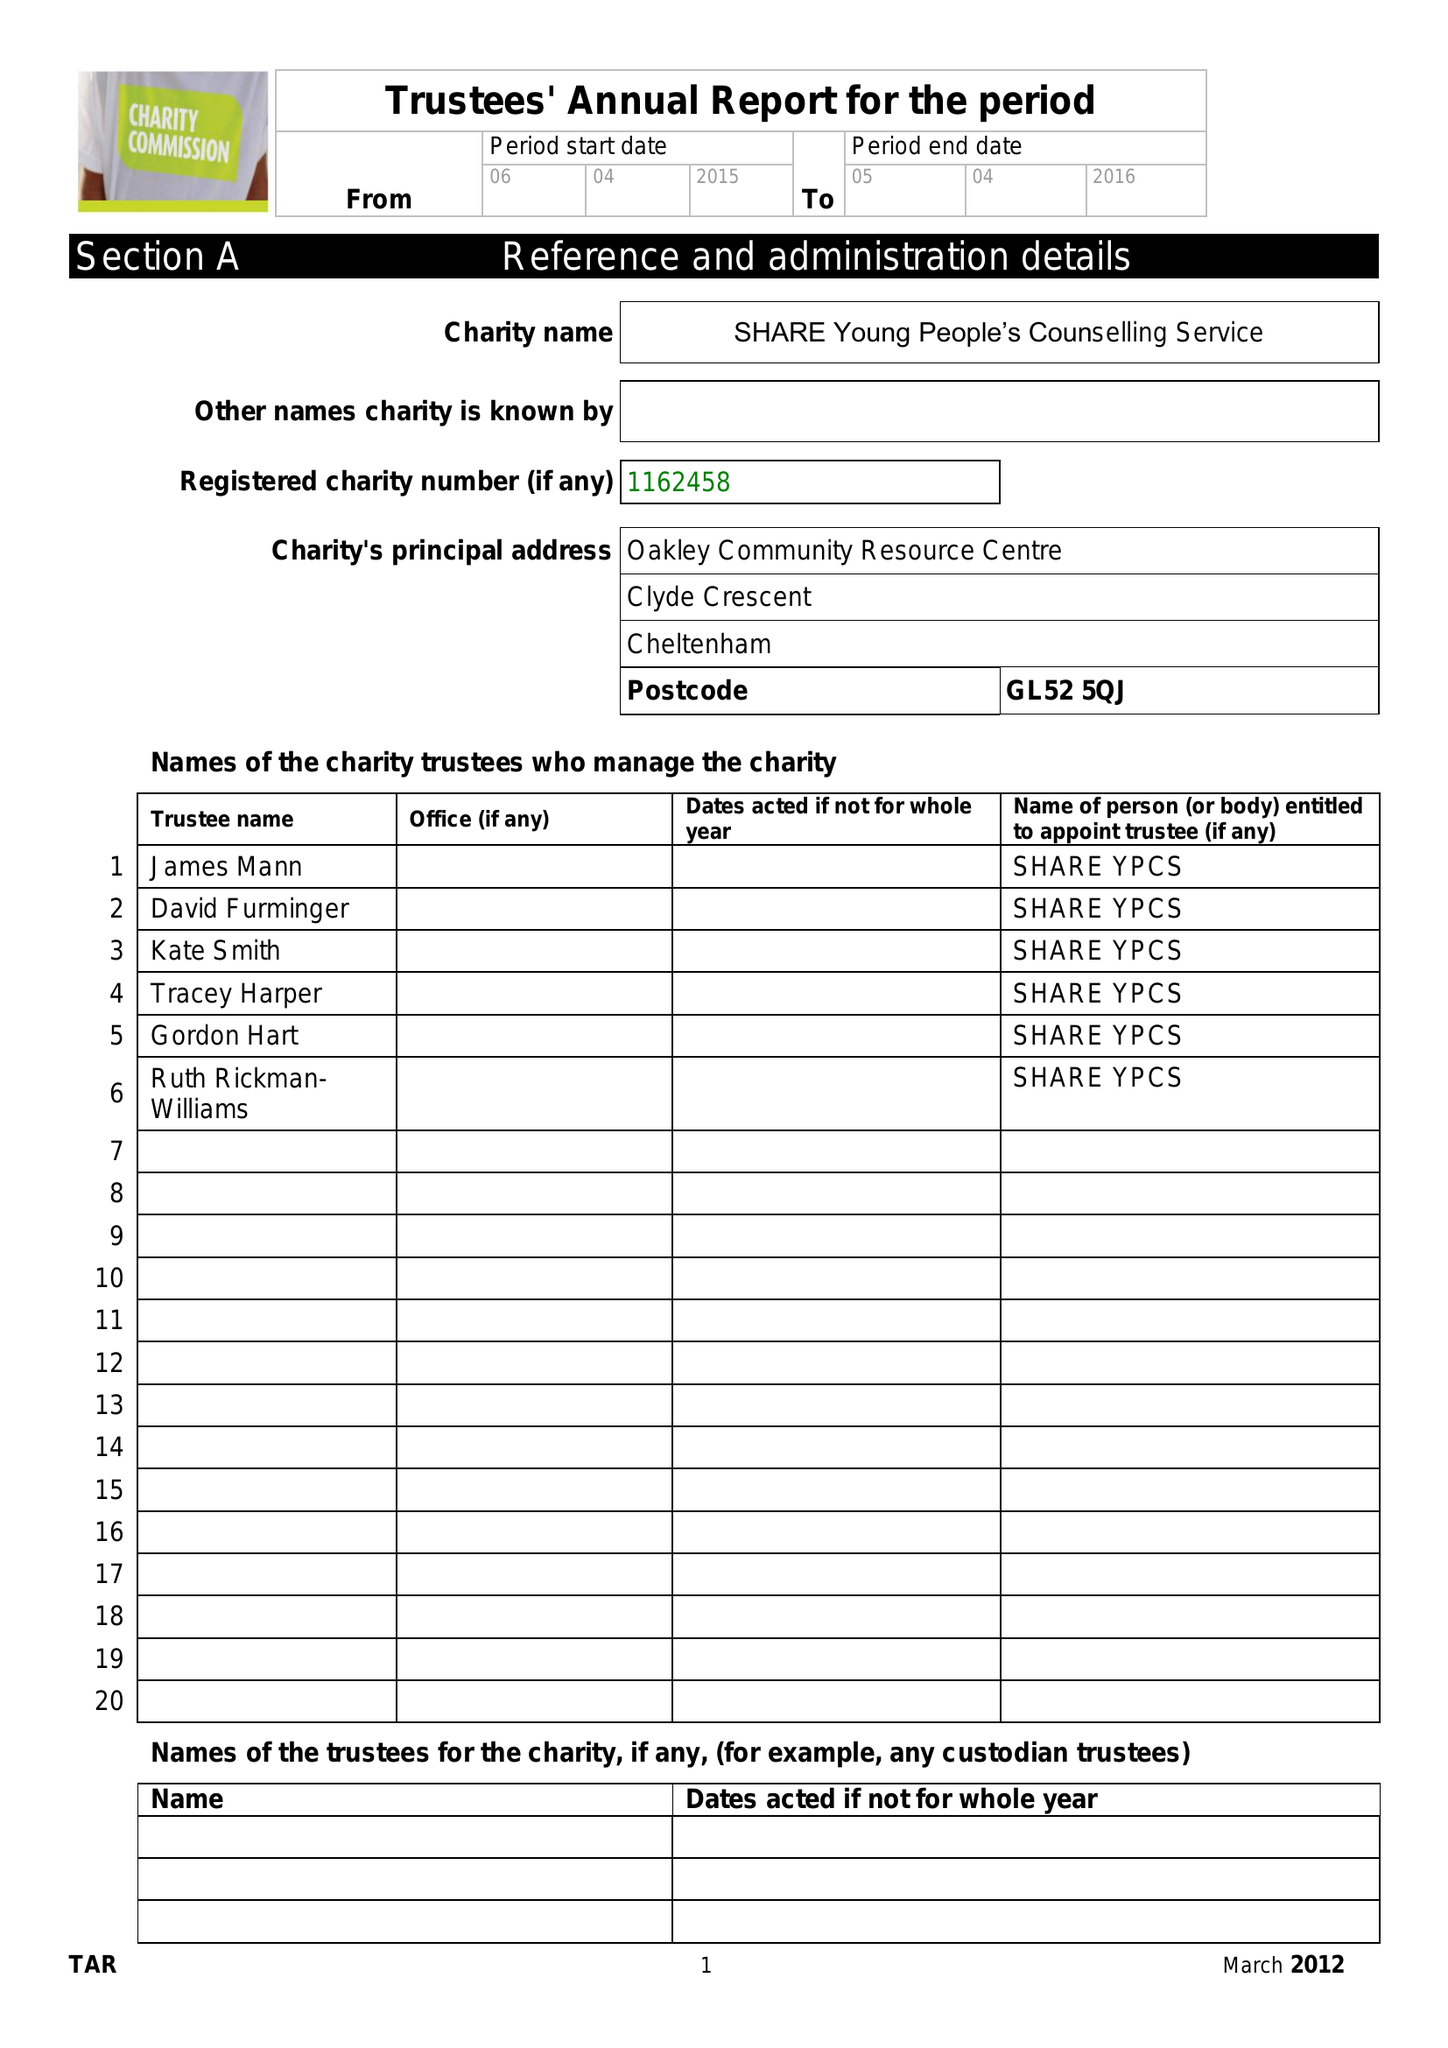What is the value for the address__post_town?
Answer the question using a single word or phrase. CHELTENHAM 